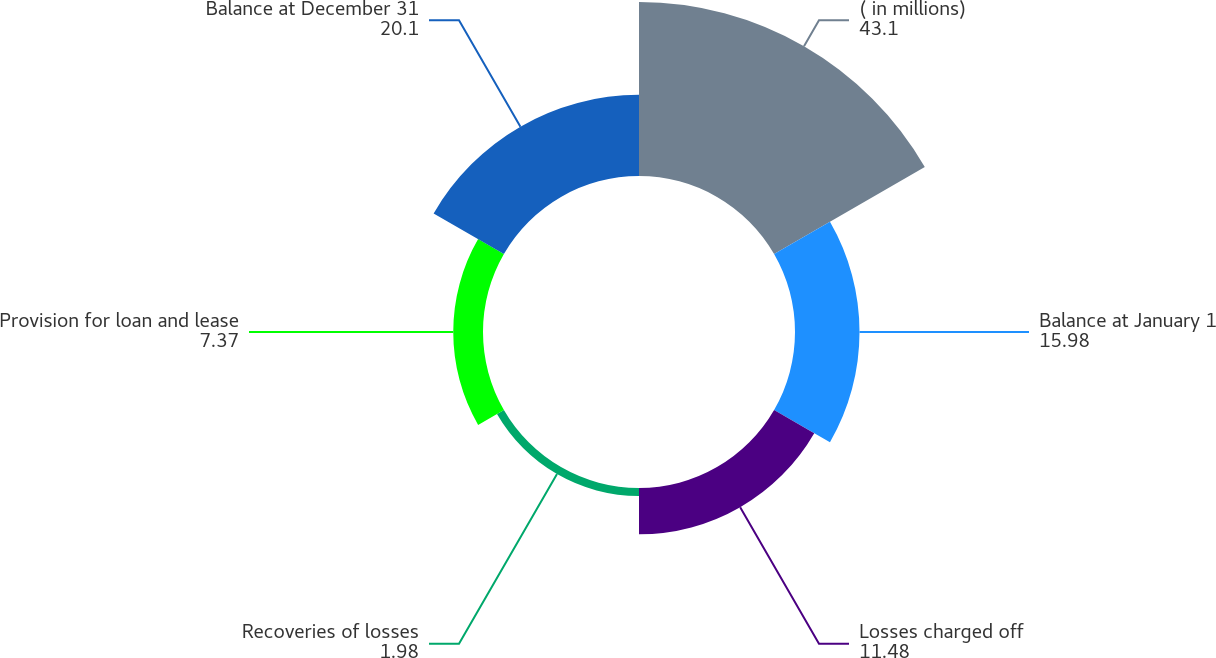Convert chart to OTSL. <chart><loc_0><loc_0><loc_500><loc_500><pie_chart><fcel>( in millions)<fcel>Balance at January 1<fcel>Losses charged off<fcel>Recoveries of losses<fcel>Provision for loan and lease<fcel>Balance at December 31<nl><fcel>43.1%<fcel>15.98%<fcel>11.48%<fcel>1.98%<fcel>7.37%<fcel>20.1%<nl></chart> 